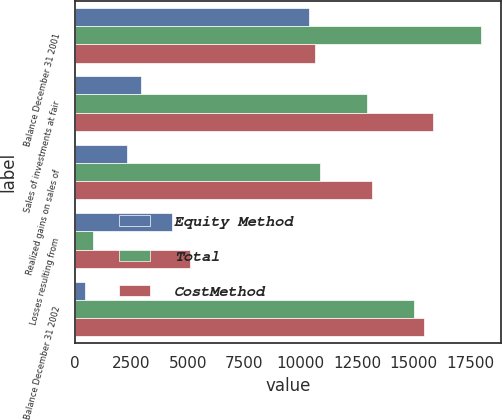Convert chart. <chart><loc_0><loc_0><loc_500><loc_500><stacked_bar_chart><ecel><fcel>Balance December 31 2001<fcel>Sales of investments at fair<fcel>Realized gains on sales of<fcel>Losses resulting from<fcel>Balance December 31 2002<nl><fcel>Equity Method<fcel>10387<fcel>2940<fcel>2326<fcel>4288<fcel>436<nl><fcel>Total<fcel>17972<fcel>12941<fcel>10844<fcel>794<fcel>15006<nl><fcel>CostMethod<fcel>10615.5<fcel>15881<fcel>13170<fcel>5082<fcel>15442<nl></chart> 